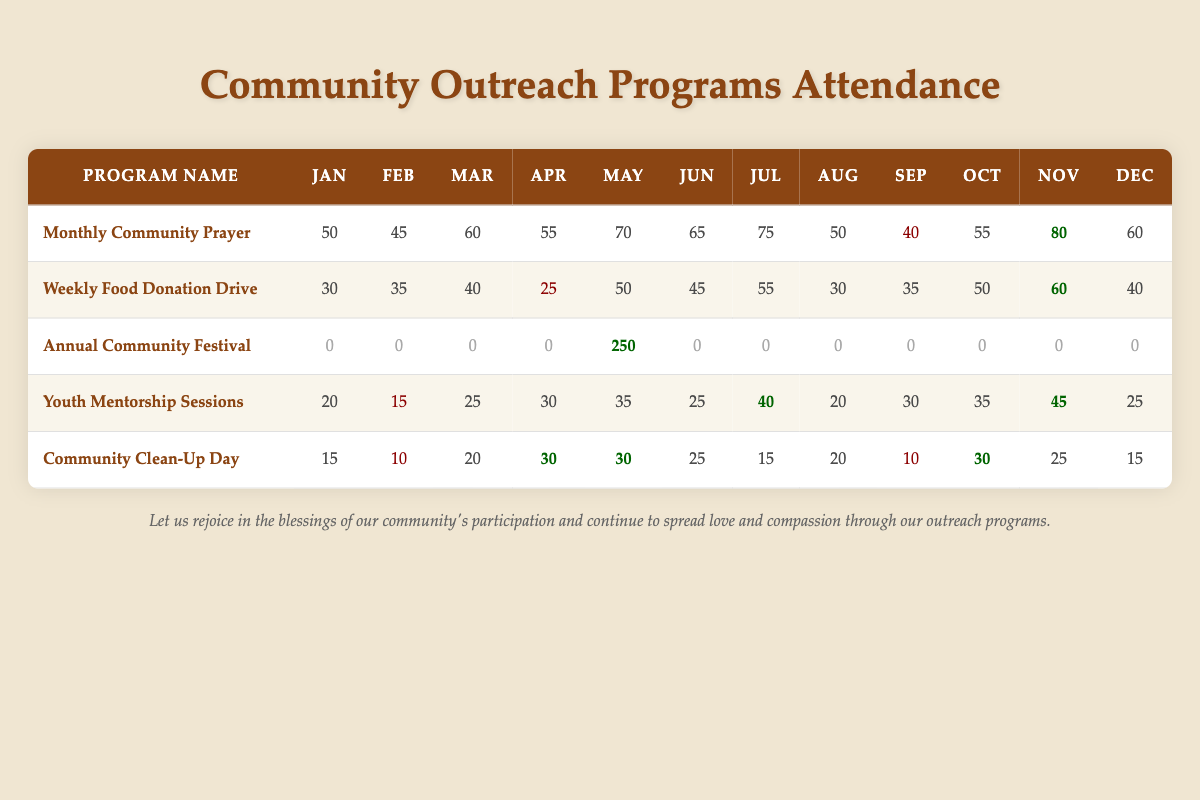What was the highest attendance for the Monthly Community Prayer? The table shows that the highest attendance for the Monthly Community Prayer was in November, with a recorded attendance of 80 participants.
Answer: 80 What was the lowest attendance for the Weekly Food Donation Drive? Referring to the table, the lowest attendance for the Weekly Food Donation Drive occurred in April with 25 participants.
Answer: 25 What is the total attendance for the Annual Community Festival? The Annual Community Festival had attendance only in May, which was 250. All other months showed zero attendance. Thus, the total attendance is 250.
Answer: 250 Which program had the highest average monthly attendance? To find the average, each program's total attendance over the year needs to be calculated and then divided by 12. The Monthly Community Prayer has a total attendance of 680, leading to an average of 680/12 = 56.67, which is higher than the other programs.
Answer: Monthly Community Prayer Did the Youth Mentorship Sessions have a higher attendance in December or January? In the table, the Youth Mentorship Sessions had 25 attendees in December and 20 in January. Therefore, December had the higher attendance.
Answer: Yes What was the difference in attendance between the highest and lowest attended month for the Community Clean-Up Day? The highest attendance for Community Clean-Up Day was 30 in April and the lowest was 10 in February. The difference is 30 - 10 = 20.
Answer: 20 What percentage of attendees in May were for the Annual Community Festival compared to the total attendance across all programs in that month? In May, the Annual Community Festival had 250 attendees. The other programs had contributions of 70, 50, 35, 30, and 30, which sum up to 215. Thus, total attendance in May is 250 + 215 = 465. The percentage is (250/465) * 100 = 53.76%.
Answer: 53.76% In which month did the Youth Mentorship Sessions have their highest attendance, and what was it? The highest attendance for the Youth Mentorship Sessions was in November, with a total of 45 participants. This can be confirmed by checking the attendance numbers listed in the table.
Answer: November, 45 Which program consistently had zero attendance for 11 out of 12 months? The program with consistent zero attendance for 11 months was the Annual Community Festival; it recorded attendance only in May.
Answer: Annual Community Festival What was the overall trend in attendance for the Monthly Community Prayer throughout the year? By observing the recorded attendance, it can be noted that the Monthly Community Prayer had fluctuations but increased over the months, peaking in November with 80 attendants before decreasing again by December, suggesting a growth trend leading into the end of the year.
Answer: Fluctuating with a peak in November What was the total attendance across all programs in October? In October, the total attendance across all programs was 55 (Monthly Community Prayer) + 50 (Weekly Food Donation Drive) + 0 (Annual Community Festival) + 35 (Youth Mentorship Sessions) + 30 (Community Clean-Up Day) = 170.
Answer: 170 